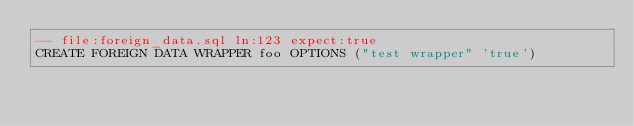Convert code to text. <code><loc_0><loc_0><loc_500><loc_500><_SQL_>-- file:foreign_data.sql ln:123 expect:true
CREATE FOREIGN DATA WRAPPER foo OPTIONS ("test wrapper" 'true')
</code> 